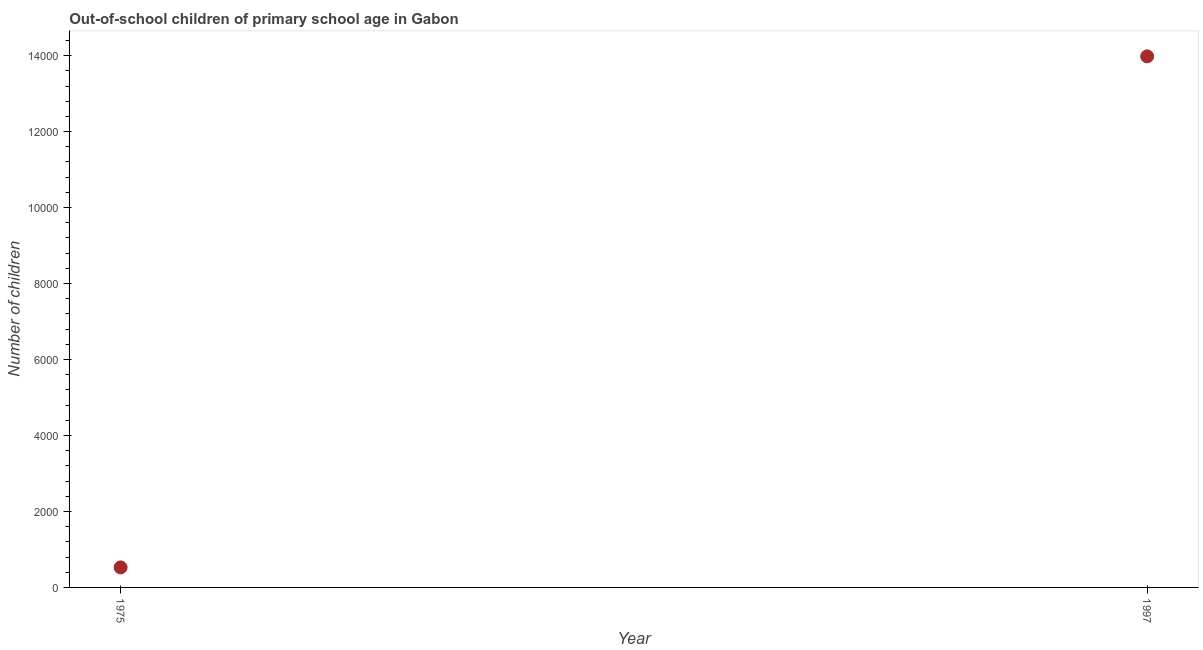What is the number of out-of-school children in 1975?
Your answer should be compact. 527. Across all years, what is the maximum number of out-of-school children?
Offer a terse response. 1.40e+04. Across all years, what is the minimum number of out-of-school children?
Offer a terse response. 527. In which year was the number of out-of-school children minimum?
Make the answer very short. 1975. What is the sum of the number of out-of-school children?
Offer a terse response. 1.45e+04. What is the difference between the number of out-of-school children in 1975 and 1997?
Give a very brief answer. -1.35e+04. What is the average number of out-of-school children per year?
Your response must be concise. 7253.5. What is the median number of out-of-school children?
Provide a short and direct response. 7253.5. In how many years, is the number of out-of-school children greater than 5200 ?
Keep it short and to the point. 1. Do a majority of the years between 1997 and 1975 (inclusive) have number of out-of-school children greater than 4400 ?
Provide a short and direct response. No. What is the ratio of the number of out-of-school children in 1975 to that in 1997?
Provide a short and direct response. 0.04. In how many years, is the number of out-of-school children greater than the average number of out-of-school children taken over all years?
Give a very brief answer. 1. Does the number of out-of-school children monotonically increase over the years?
Give a very brief answer. Yes. How many dotlines are there?
Your response must be concise. 1. How many years are there in the graph?
Offer a terse response. 2. Are the values on the major ticks of Y-axis written in scientific E-notation?
Provide a short and direct response. No. What is the title of the graph?
Provide a succinct answer. Out-of-school children of primary school age in Gabon. What is the label or title of the X-axis?
Keep it short and to the point. Year. What is the label or title of the Y-axis?
Offer a very short reply. Number of children. What is the Number of children in 1975?
Provide a succinct answer. 527. What is the Number of children in 1997?
Ensure brevity in your answer.  1.40e+04. What is the difference between the Number of children in 1975 and 1997?
Keep it short and to the point. -1.35e+04. What is the ratio of the Number of children in 1975 to that in 1997?
Provide a succinct answer. 0.04. 